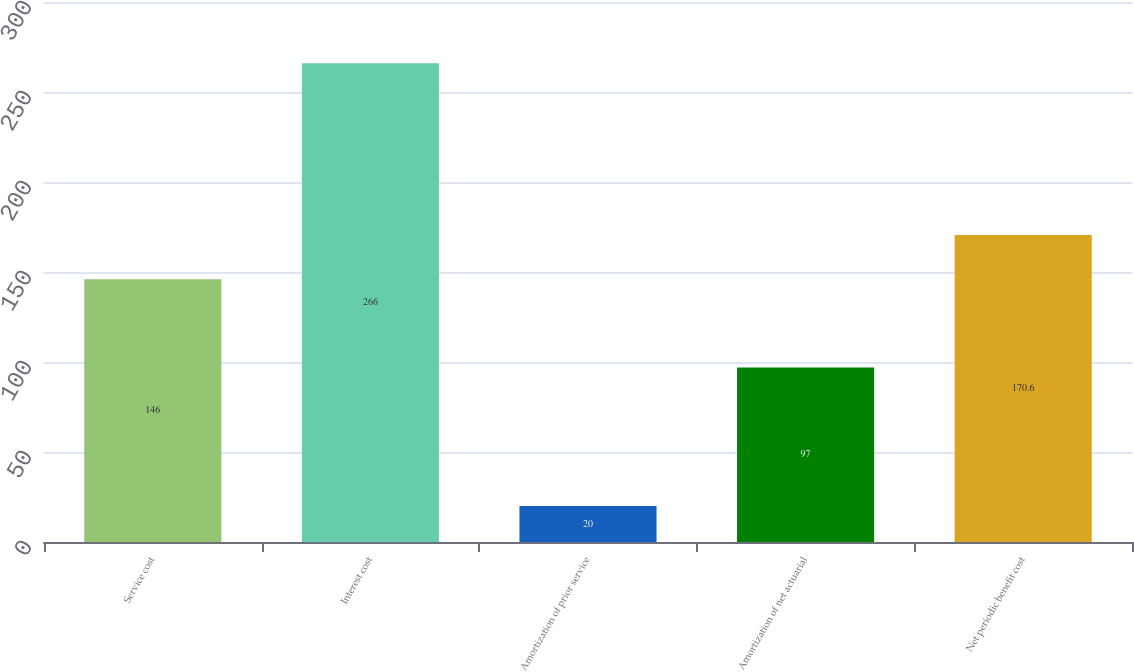<chart> <loc_0><loc_0><loc_500><loc_500><bar_chart><fcel>Service cost<fcel>Interest cost<fcel>Amortization of prior service<fcel>Amortization of net actuarial<fcel>Net periodic benefit cost<nl><fcel>146<fcel>266<fcel>20<fcel>97<fcel>170.6<nl></chart> 